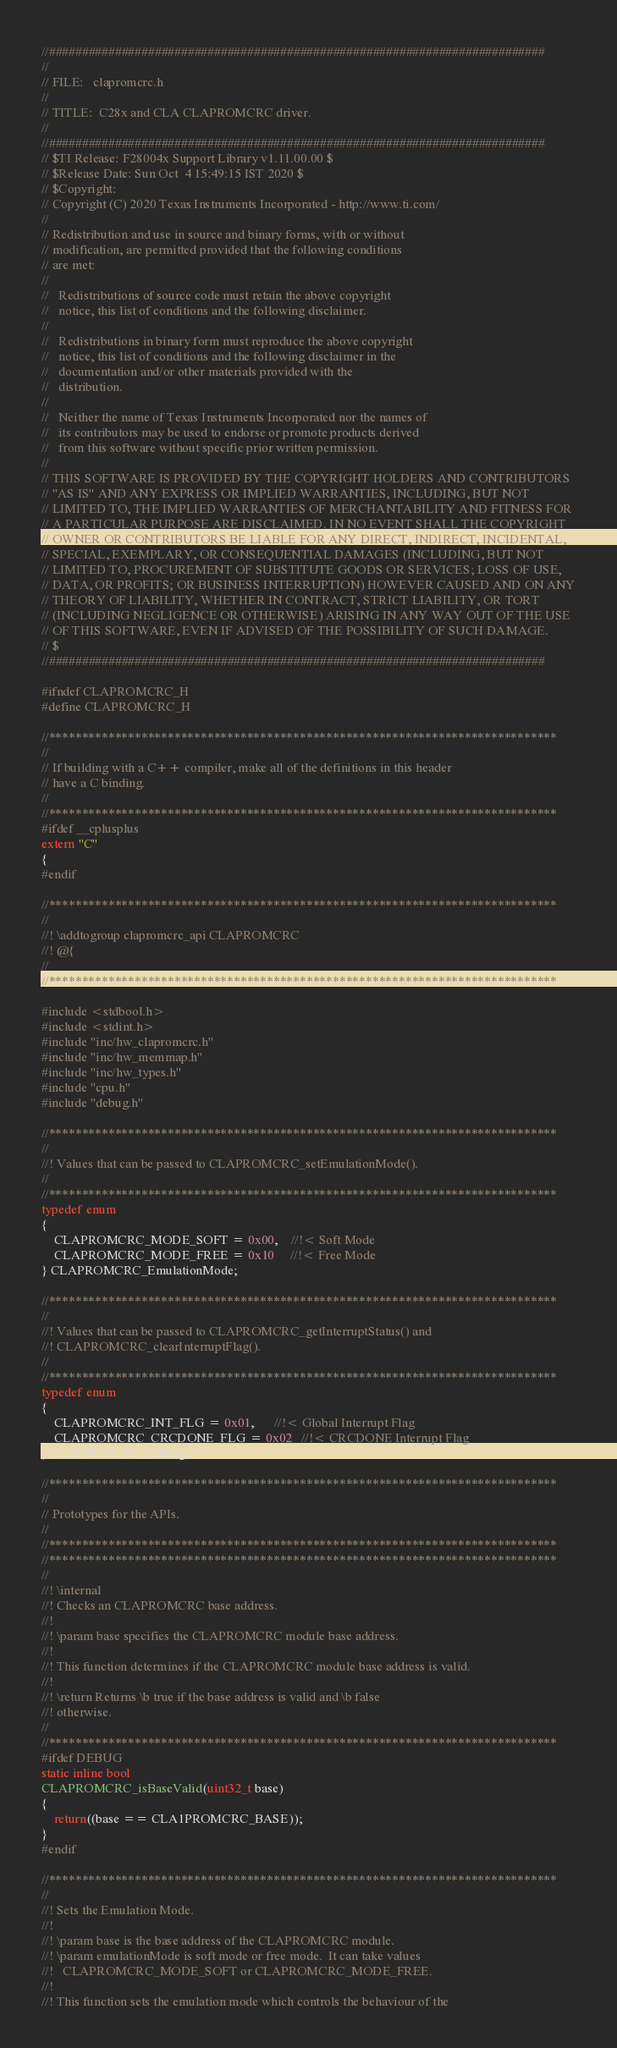<code> <loc_0><loc_0><loc_500><loc_500><_C_>//###########################################################################
//
// FILE:   clapromcrc.h
//
// TITLE:  C28x and CLA CLAPROMCRC driver.
//
//###########################################################################
// $TI Release: F28004x Support Library v1.11.00.00 $
// $Release Date: Sun Oct  4 15:49:15 IST 2020 $
// $Copyright:
// Copyright (C) 2020 Texas Instruments Incorporated - http://www.ti.com/
//
// Redistribution and use in source and binary forms, with or without 
// modification, are permitted provided that the following conditions 
// are met:
// 
//   Redistributions of source code must retain the above copyright 
//   notice, this list of conditions and the following disclaimer.
// 
//   Redistributions in binary form must reproduce the above copyright
//   notice, this list of conditions and the following disclaimer in the 
//   documentation and/or other materials provided with the   
//   distribution.
// 
//   Neither the name of Texas Instruments Incorporated nor the names of
//   its contributors may be used to endorse or promote products derived
//   from this software without specific prior written permission.
// 
// THIS SOFTWARE IS PROVIDED BY THE COPYRIGHT HOLDERS AND CONTRIBUTORS 
// "AS IS" AND ANY EXPRESS OR IMPLIED WARRANTIES, INCLUDING, BUT NOT 
// LIMITED TO, THE IMPLIED WARRANTIES OF MERCHANTABILITY AND FITNESS FOR
// A PARTICULAR PURPOSE ARE DISCLAIMED. IN NO EVENT SHALL THE COPYRIGHT 
// OWNER OR CONTRIBUTORS BE LIABLE FOR ANY DIRECT, INDIRECT, INCIDENTAL, 
// SPECIAL, EXEMPLARY, OR CONSEQUENTIAL DAMAGES (INCLUDING, BUT NOT 
// LIMITED TO, PROCUREMENT OF SUBSTITUTE GOODS OR SERVICES; LOSS OF USE,
// DATA, OR PROFITS; OR BUSINESS INTERRUPTION) HOWEVER CAUSED AND ON ANY
// THEORY OF LIABILITY, WHETHER IN CONTRACT, STRICT LIABILITY, OR TORT 
// (INCLUDING NEGLIGENCE OR OTHERWISE) ARISING IN ANY WAY OUT OF THE USE 
// OF THIS SOFTWARE, EVEN IF ADVISED OF THE POSSIBILITY OF SUCH DAMAGE.
// $
//###########################################################################

#ifndef CLAPROMCRC_H
#define CLAPROMCRC_H

//*****************************************************************************
//
// If building with a C++ compiler, make all of the definitions in this header
// have a C binding.
//
//*****************************************************************************
#ifdef __cplusplus
extern "C"
{
#endif

//*****************************************************************************
//
//! \addtogroup clapromcrc_api CLAPROMCRC
//! @{
//
//*****************************************************************************

#include <stdbool.h>
#include <stdint.h>
#include "inc/hw_clapromcrc.h"
#include "inc/hw_memmap.h"
#include "inc/hw_types.h"
#include "cpu.h"
#include "debug.h"

//*****************************************************************************
//
//! Values that can be passed to CLAPROMCRC_setEmulationMode().
//
//*****************************************************************************
typedef enum
{
    CLAPROMCRC_MODE_SOFT = 0x00,    //!< Soft Mode
    CLAPROMCRC_MODE_FREE = 0x10     //!< Free Mode
} CLAPROMCRC_EmulationMode;

//*****************************************************************************
//
//! Values that can be passed to CLAPROMCRC_getInterruptStatus() and
//! CLAPROMCRC_clearInterruptFlag().
//
//*****************************************************************************
typedef enum
{
    CLAPROMCRC_INT_FLG = 0x01,      //!< Global Interrupt Flag
    CLAPROMCRC_CRCDONE_FLG = 0x02   //!< CRCDONE Interrupt Flag
} CLAPROMCRC_IntFlag;

//*****************************************************************************
//
// Prototypes for the APIs.
//
//*****************************************************************************
//*****************************************************************************
//
//! \internal
//! Checks an CLAPROMCRC base address.
//!
//! \param base specifies the CLAPROMCRC module base address.
//!
//! This function determines if the CLAPROMCRC module base address is valid.
//!
//! \return Returns \b true if the base address is valid and \b false
//! otherwise.
//
//*****************************************************************************
#ifdef DEBUG
static inline bool
CLAPROMCRC_isBaseValid(uint32_t base)
{
    return((base == CLA1PROMCRC_BASE));
}
#endif

//*****************************************************************************
//
//! Sets the Emulation Mode.
//!
//! \param base is the base address of the CLAPROMCRC module.
//! \param emulationMode is soft mode or free mode.  It can take values
//!   CLAPROMCRC_MODE_SOFT or CLAPROMCRC_MODE_FREE.
//!
//! This function sets the emulation mode which controls the behaviour of the</code> 